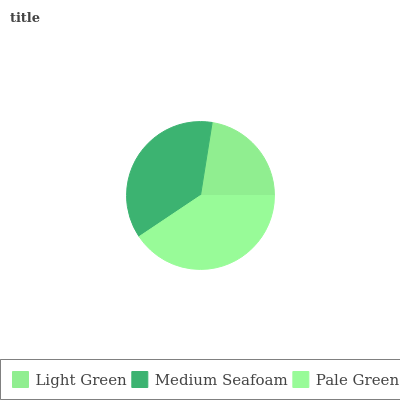Is Light Green the minimum?
Answer yes or no. Yes. Is Pale Green the maximum?
Answer yes or no. Yes. Is Medium Seafoam the minimum?
Answer yes or no. No. Is Medium Seafoam the maximum?
Answer yes or no. No. Is Medium Seafoam greater than Light Green?
Answer yes or no. Yes. Is Light Green less than Medium Seafoam?
Answer yes or no. Yes. Is Light Green greater than Medium Seafoam?
Answer yes or no. No. Is Medium Seafoam less than Light Green?
Answer yes or no. No. Is Medium Seafoam the high median?
Answer yes or no. Yes. Is Medium Seafoam the low median?
Answer yes or no. Yes. Is Light Green the high median?
Answer yes or no. No. Is Light Green the low median?
Answer yes or no. No. 